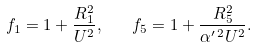<formula> <loc_0><loc_0><loc_500><loc_500>f _ { 1 } = 1 + \frac { R _ { 1 } ^ { 2 } } { U ^ { 2 } } , \quad f _ { 5 } = 1 + \frac { R _ { 5 } ^ { 2 } } { \alpha ^ { \prime \, 2 } U ^ { 2 } } .</formula> 